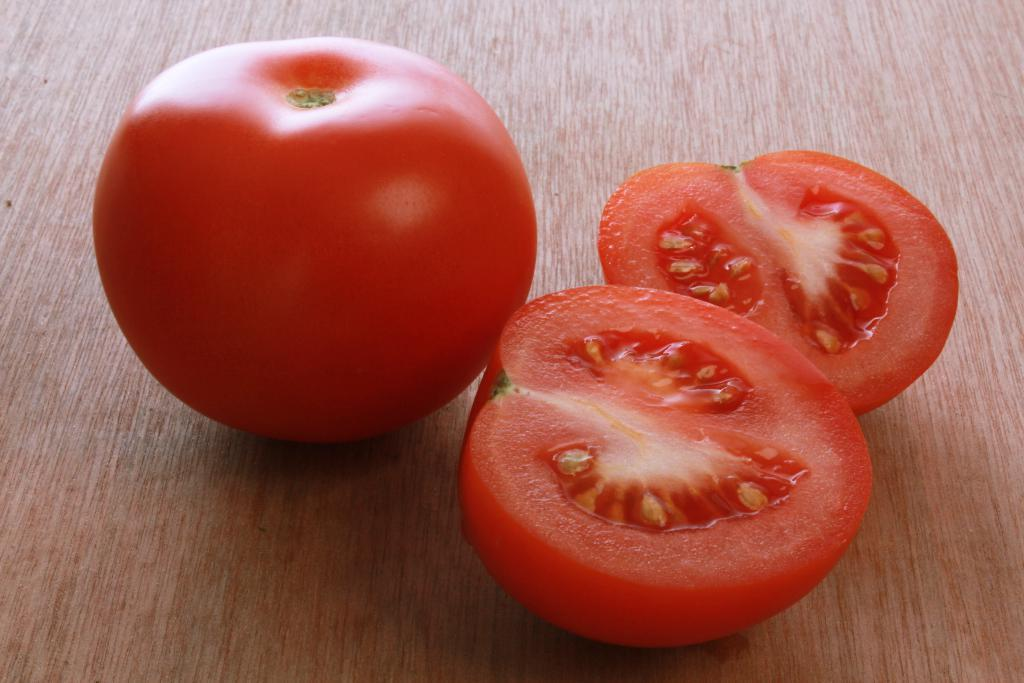What is the main subject of the image? The main subject of the image is a tomato. How is the tomato presented in the image? The tomato is in two pieces in the image. Where are the tomato and its pieces located? The tomato and its pieces are kept on a table. Can you describe the setting of the image? The image is likely taken in a room, as there is a table present. Can you tell me how many hydrants are visible in the image? There are no hydrants present in the image; it features a tomato in two pieces on a table. What type of ocean can be seen in the background of the image? There is no ocean visible in the image, as it is focused on a tomato on a table in a room. 